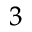Convert formula to latex. <formula><loc_0><loc_0><loc_500><loc_500>^ { 3 }</formula> 